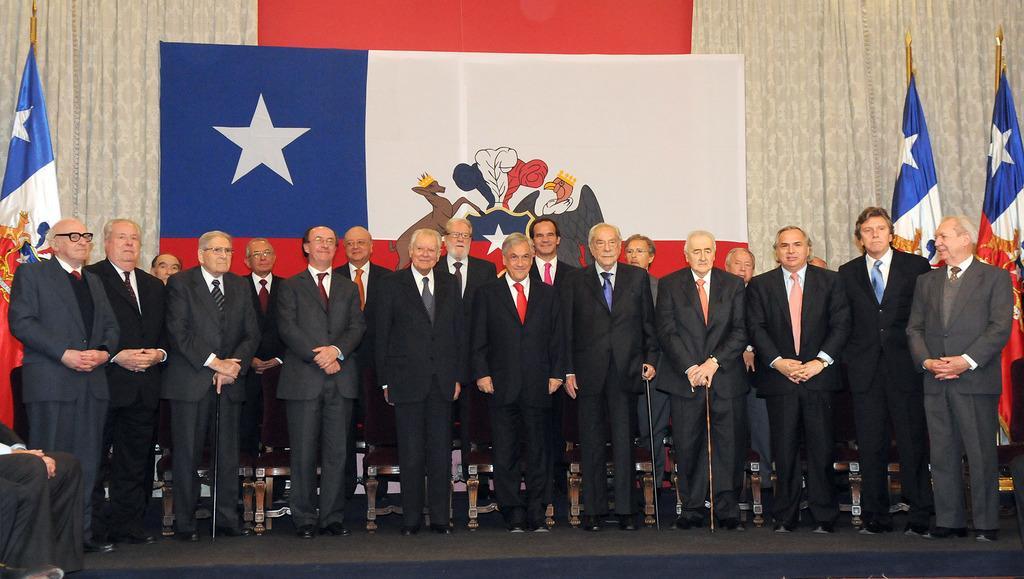Please provide a concise description of this image. In this picture there are men those who are standing in series and there are flags on the right and left side of the image. 